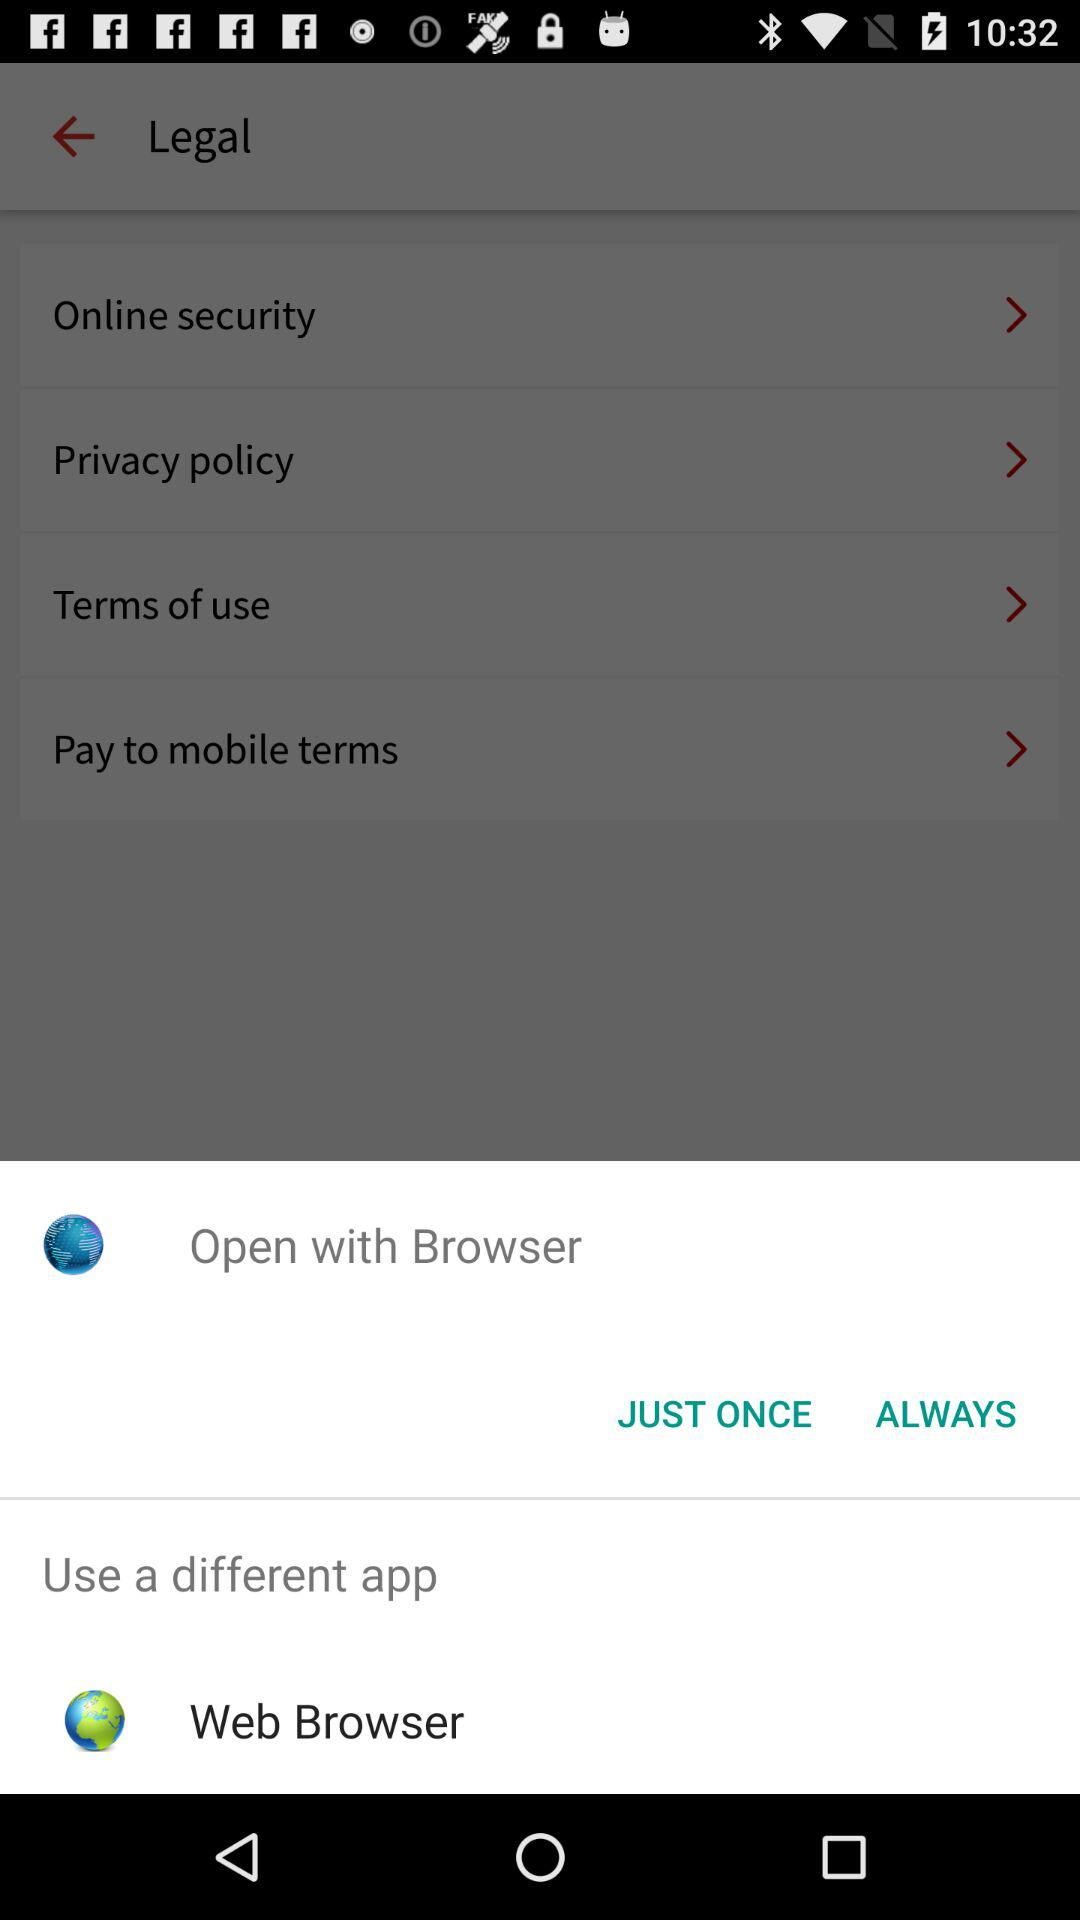Through which application can be open? You can open it through "Browser" and "Web Browser". 